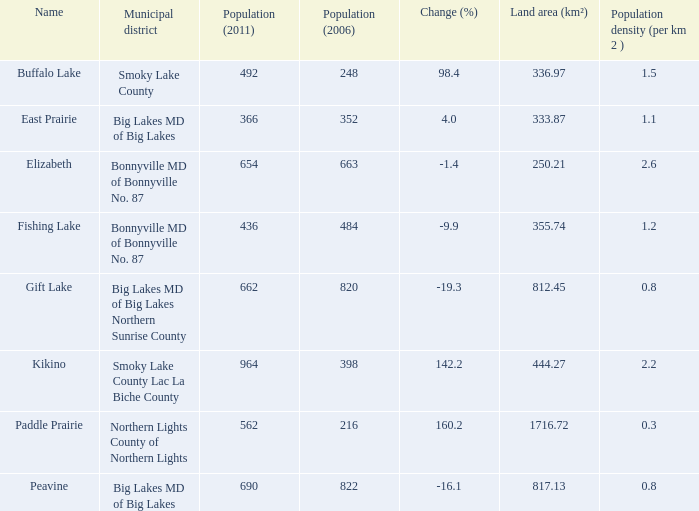In fishing lake, what is the population density in terms of residents per km2? 1.2. 